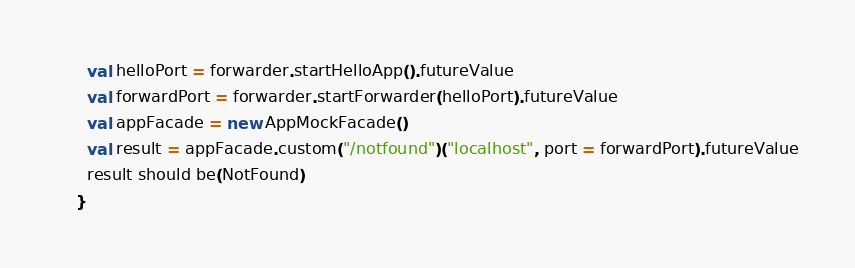Convert code to text. <code><loc_0><loc_0><loc_500><loc_500><_Scala_>      val helloPort = forwarder.startHelloApp().futureValue
      val forwardPort = forwarder.startForwarder(helloPort).futureValue
      val appFacade = new AppMockFacade()
      val result = appFacade.custom("/notfound")("localhost", port = forwardPort).futureValue
      result should be(NotFound)
    }
</code> 